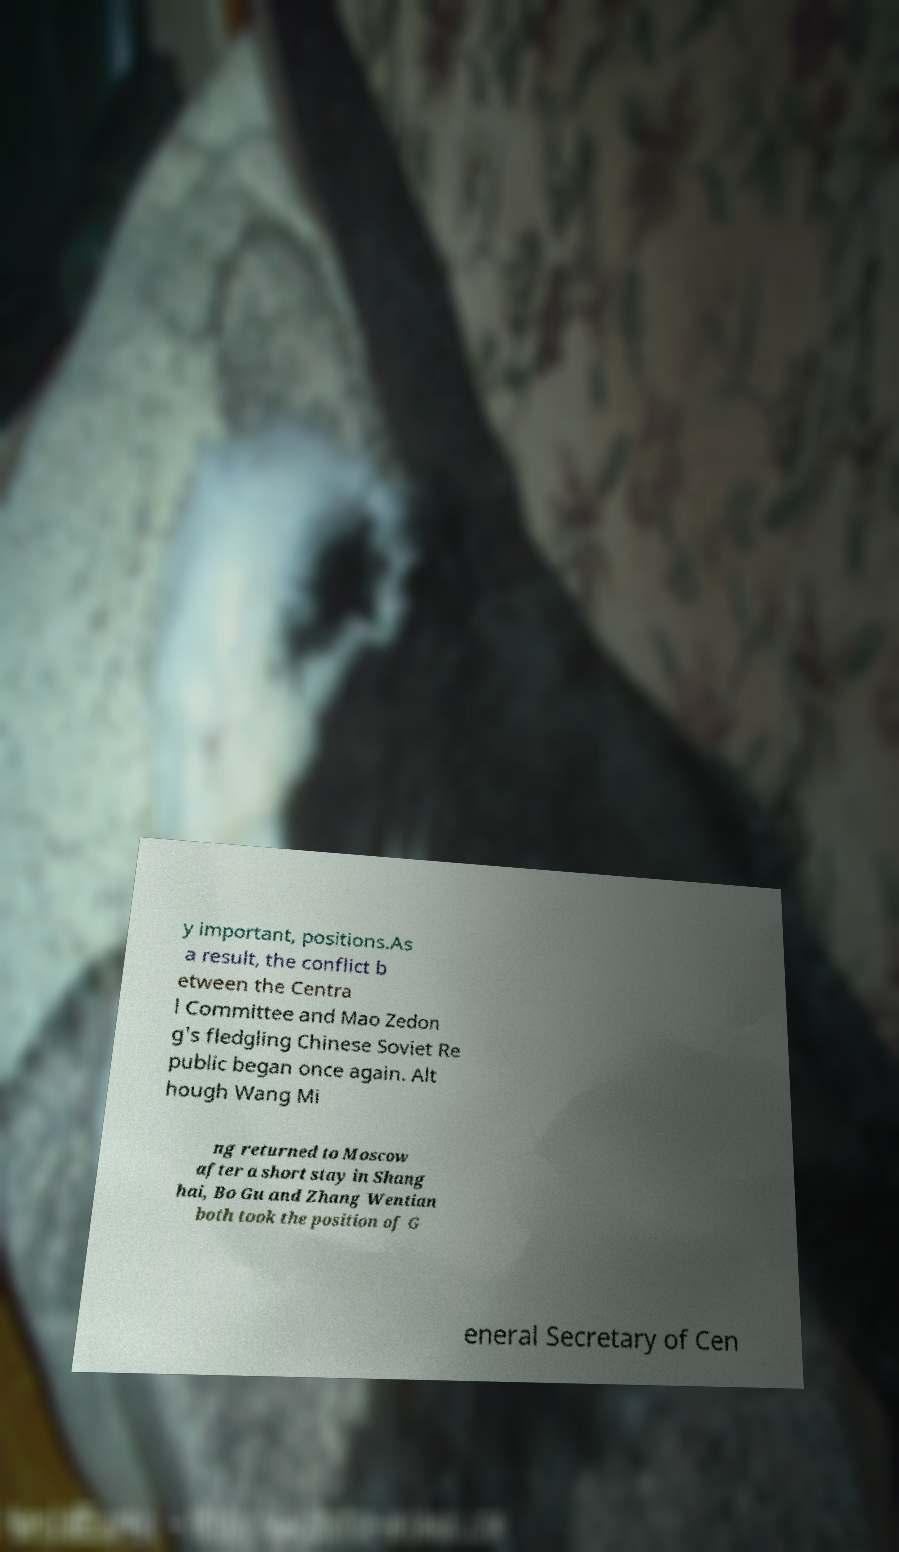For documentation purposes, I need the text within this image transcribed. Could you provide that? y important, positions.As a result, the conflict b etween the Centra l Committee and Mao Zedon g's fledgling Chinese Soviet Re public began once again. Alt hough Wang Mi ng returned to Moscow after a short stay in Shang hai, Bo Gu and Zhang Wentian both took the position of G eneral Secretary of Cen 